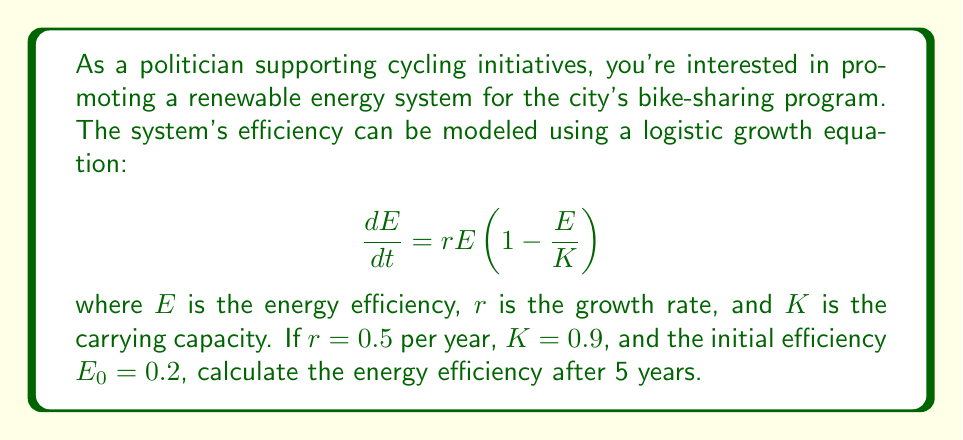Solve this math problem. To solve this problem, we need to use the solution to the logistic growth equation:

$$E(t) = \frac{KE_0}{E_0 + (K - E_0)e^{-rt}}$$

Let's substitute the given values:
$K = 0.9$, $E_0 = 0.2$, $r = 0.5$, and $t = 5$

$$E(5) = \frac{0.9 \cdot 0.2}{0.2 + (0.9 - 0.2)e^{-0.5 \cdot 5}}$$

$$= \frac{0.18}{0.2 + 0.7e^{-2.5}}$$

$$= \frac{0.18}{0.2 + 0.7 \cdot 0.0821}$$

$$= \frac{0.18}{0.2 + 0.0575}$$

$$= \frac{0.18}{0.2575}$$

$$= 0.6990$$

Therefore, the energy efficiency after 5 years is approximately 0.6990 or 69.90%.
Answer: 69.90% 